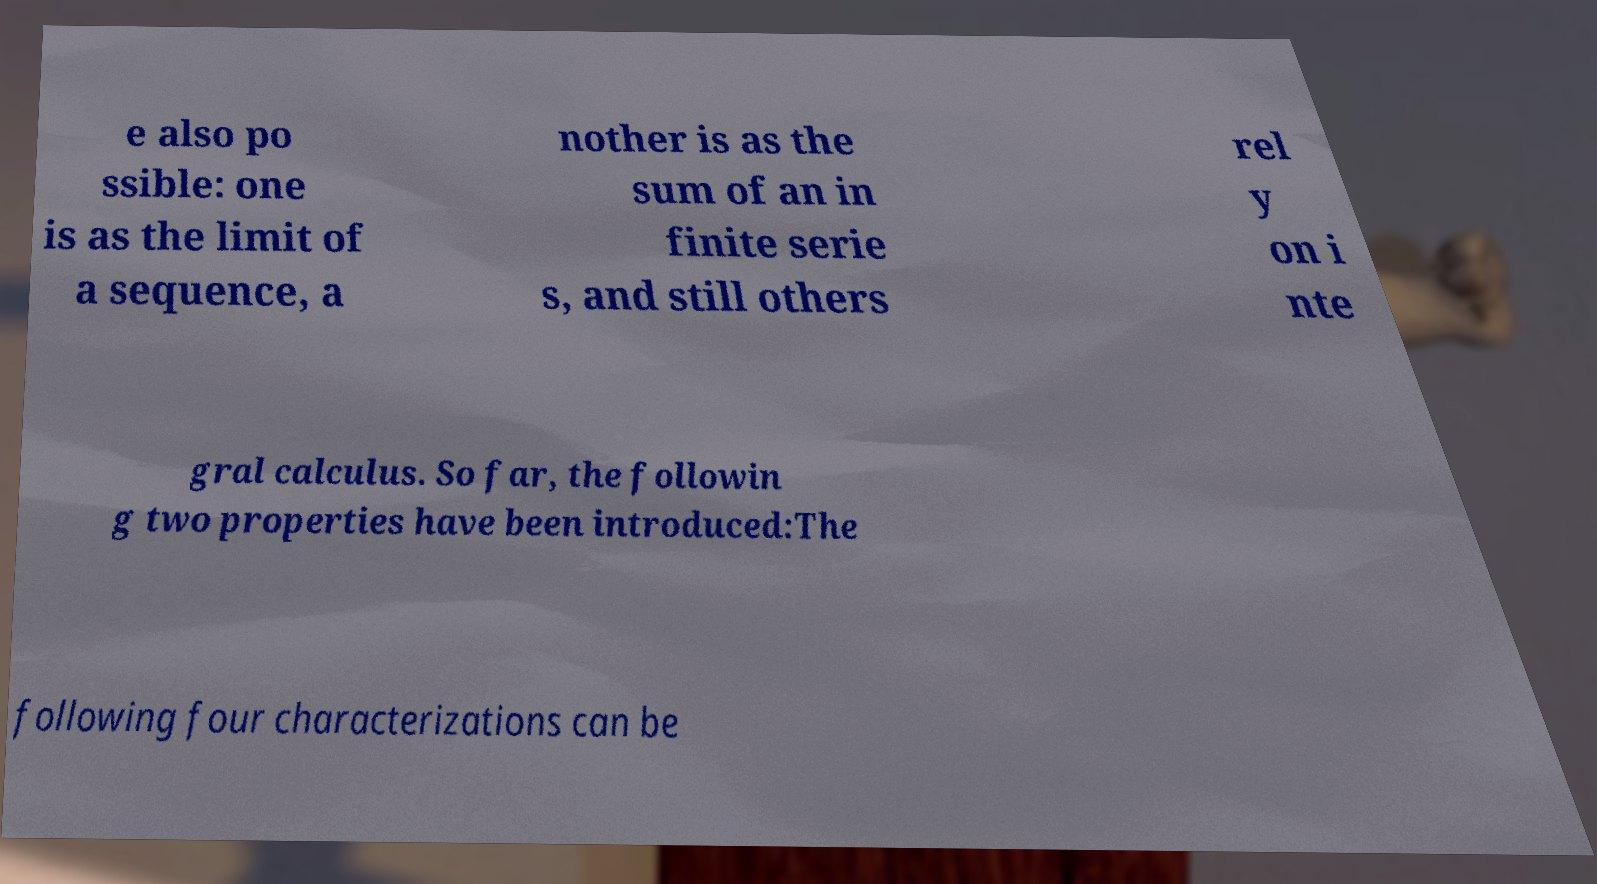Can you accurately transcribe the text from the provided image for me? e also po ssible: one is as the limit of a sequence, a nother is as the sum of an in finite serie s, and still others rel y on i nte gral calculus. So far, the followin g two properties have been introduced:The following four characterizations can be 